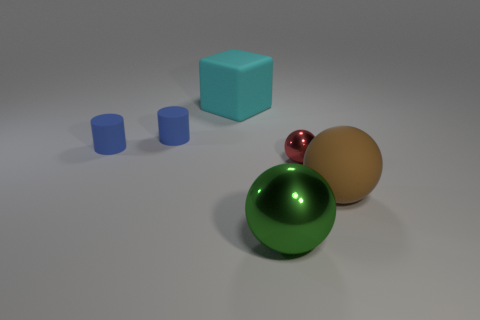Add 3 blue cylinders. How many objects exist? 9 Subtract all cylinders. How many objects are left? 4 Subtract 0 purple spheres. How many objects are left? 6 Subtract all balls. Subtract all green balls. How many objects are left? 2 Add 6 red metallic balls. How many red metallic balls are left? 7 Add 3 small blue cylinders. How many small blue cylinders exist? 5 